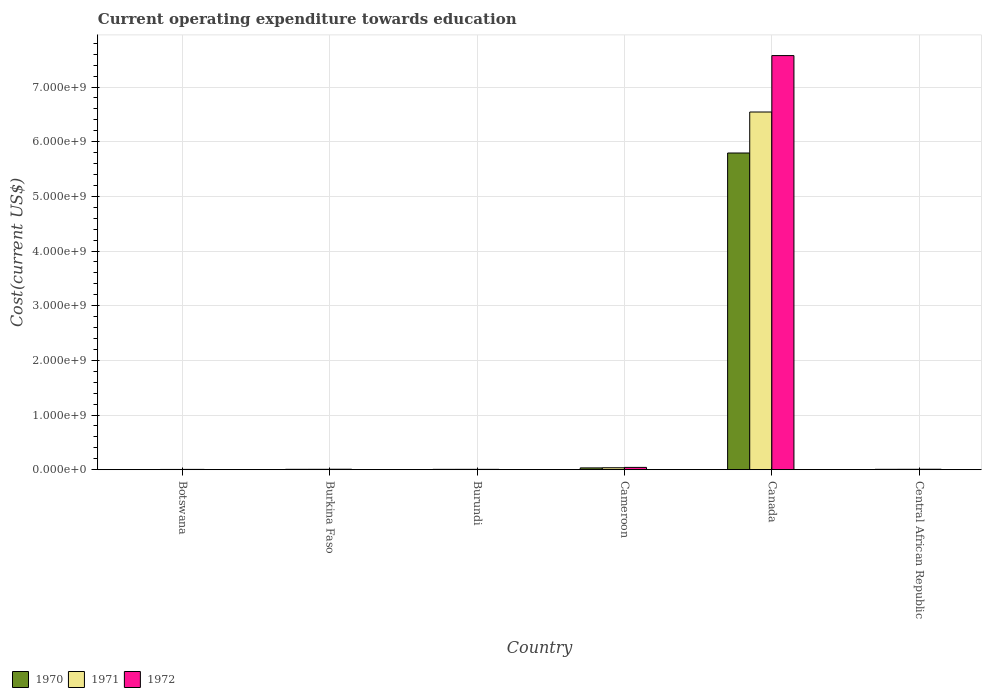How many groups of bars are there?
Keep it short and to the point. 6. Are the number of bars per tick equal to the number of legend labels?
Offer a very short reply. Yes. Are the number of bars on each tick of the X-axis equal?
Keep it short and to the point. Yes. What is the label of the 4th group of bars from the left?
Keep it short and to the point. Cameroon. In how many cases, is the number of bars for a given country not equal to the number of legend labels?
Offer a terse response. 0. What is the expenditure towards education in 1970 in Cameroon?
Offer a terse response. 3.28e+07. Across all countries, what is the maximum expenditure towards education in 1971?
Keep it short and to the point. 6.54e+09. Across all countries, what is the minimum expenditure towards education in 1970?
Keep it short and to the point. 3.52e+06. In which country was the expenditure towards education in 1970 maximum?
Your answer should be very brief. Canada. In which country was the expenditure towards education in 1972 minimum?
Ensure brevity in your answer.  Botswana. What is the total expenditure towards education in 1971 in the graph?
Offer a very short reply. 6.60e+09. What is the difference between the expenditure towards education in 1972 in Burundi and that in Central African Republic?
Your answer should be very brief. -2.09e+06. What is the difference between the expenditure towards education in 1971 in Burkina Faso and the expenditure towards education in 1970 in Burundi?
Give a very brief answer. 8.76e+05. What is the average expenditure towards education in 1970 per country?
Offer a terse response. 9.75e+08. What is the difference between the expenditure towards education of/in 1971 and expenditure towards education of/in 1970 in Central African Republic?
Keep it short and to the point. 4.30e+05. In how many countries, is the expenditure towards education in 1972 greater than 4000000000 US$?
Your answer should be compact. 1. What is the ratio of the expenditure towards education in 1970 in Burundi to that in Canada?
Offer a very short reply. 0. What is the difference between the highest and the second highest expenditure towards education in 1972?
Keep it short and to the point. 7.53e+09. What is the difference between the highest and the lowest expenditure towards education in 1971?
Your answer should be compact. 6.54e+09. What does the 2nd bar from the left in Burundi represents?
Your response must be concise. 1971. Is it the case that in every country, the sum of the expenditure towards education in 1970 and expenditure towards education in 1971 is greater than the expenditure towards education in 1972?
Provide a succinct answer. Yes. What is the difference between two consecutive major ticks on the Y-axis?
Offer a very short reply. 1.00e+09. Are the values on the major ticks of Y-axis written in scientific E-notation?
Offer a terse response. Yes. What is the title of the graph?
Ensure brevity in your answer.  Current operating expenditure towards education. Does "1961" appear as one of the legend labels in the graph?
Keep it short and to the point. No. What is the label or title of the X-axis?
Provide a short and direct response. Country. What is the label or title of the Y-axis?
Your response must be concise. Cost(current US$). What is the Cost(current US$) in 1970 in Botswana?
Offer a terse response. 3.52e+06. What is the Cost(current US$) of 1971 in Botswana?
Offer a very short reply. 4.56e+06. What is the Cost(current US$) in 1972 in Botswana?
Ensure brevity in your answer.  5.45e+06. What is the Cost(current US$) in 1970 in Burkina Faso?
Provide a short and direct response. 6.88e+06. What is the Cost(current US$) in 1971 in Burkina Faso?
Give a very brief answer. 7.23e+06. What is the Cost(current US$) in 1972 in Burkina Faso?
Offer a terse response. 8.66e+06. What is the Cost(current US$) of 1970 in Burundi?
Offer a very short reply. 6.35e+06. What is the Cost(current US$) in 1971 in Burundi?
Make the answer very short. 6.58e+06. What is the Cost(current US$) in 1972 in Burundi?
Offer a very short reply. 6.36e+06. What is the Cost(current US$) of 1970 in Cameroon?
Make the answer very short. 3.28e+07. What is the Cost(current US$) of 1971 in Cameroon?
Make the answer very short. 3.57e+07. What is the Cost(current US$) in 1972 in Cameroon?
Provide a short and direct response. 4.21e+07. What is the Cost(current US$) of 1970 in Canada?
Keep it short and to the point. 5.79e+09. What is the Cost(current US$) of 1971 in Canada?
Make the answer very short. 6.54e+09. What is the Cost(current US$) in 1972 in Canada?
Your answer should be very brief. 7.58e+09. What is the Cost(current US$) of 1970 in Central African Republic?
Your response must be concise. 6.93e+06. What is the Cost(current US$) of 1971 in Central African Republic?
Ensure brevity in your answer.  7.36e+06. What is the Cost(current US$) of 1972 in Central African Republic?
Keep it short and to the point. 8.45e+06. Across all countries, what is the maximum Cost(current US$) in 1970?
Offer a very short reply. 5.79e+09. Across all countries, what is the maximum Cost(current US$) of 1971?
Offer a very short reply. 6.54e+09. Across all countries, what is the maximum Cost(current US$) in 1972?
Your response must be concise. 7.58e+09. Across all countries, what is the minimum Cost(current US$) in 1970?
Provide a short and direct response. 3.52e+06. Across all countries, what is the minimum Cost(current US$) in 1971?
Your answer should be compact. 4.56e+06. Across all countries, what is the minimum Cost(current US$) in 1972?
Keep it short and to the point. 5.45e+06. What is the total Cost(current US$) of 1970 in the graph?
Provide a short and direct response. 5.85e+09. What is the total Cost(current US$) of 1971 in the graph?
Offer a very short reply. 6.60e+09. What is the total Cost(current US$) in 1972 in the graph?
Keep it short and to the point. 7.65e+09. What is the difference between the Cost(current US$) of 1970 in Botswana and that in Burkina Faso?
Offer a terse response. -3.35e+06. What is the difference between the Cost(current US$) of 1971 in Botswana and that in Burkina Faso?
Provide a short and direct response. -2.66e+06. What is the difference between the Cost(current US$) of 1972 in Botswana and that in Burkina Faso?
Give a very brief answer. -3.21e+06. What is the difference between the Cost(current US$) in 1970 in Botswana and that in Burundi?
Your response must be concise. -2.83e+06. What is the difference between the Cost(current US$) in 1971 in Botswana and that in Burundi?
Offer a terse response. -2.02e+06. What is the difference between the Cost(current US$) in 1972 in Botswana and that in Burundi?
Ensure brevity in your answer.  -9.03e+05. What is the difference between the Cost(current US$) of 1970 in Botswana and that in Cameroon?
Provide a succinct answer. -2.93e+07. What is the difference between the Cost(current US$) in 1971 in Botswana and that in Cameroon?
Give a very brief answer. -3.12e+07. What is the difference between the Cost(current US$) in 1972 in Botswana and that in Cameroon?
Give a very brief answer. -3.66e+07. What is the difference between the Cost(current US$) in 1970 in Botswana and that in Canada?
Your response must be concise. -5.79e+09. What is the difference between the Cost(current US$) in 1971 in Botswana and that in Canada?
Provide a succinct answer. -6.54e+09. What is the difference between the Cost(current US$) of 1972 in Botswana and that in Canada?
Give a very brief answer. -7.57e+09. What is the difference between the Cost(current US$) in 1970 in Botswana and that in Central African Republic?
Your response must be concise. -3.41e+06. What is the difference between the Cost(current US$) of 1971 in Botswana and that in Central African Republic?
Give a very brief answer. -2.80e+06. What is the difference between the Cost(current US$) in 1972 in Botswana and that in Central African Republic?
Your answer should be very brief. -2.99e+06. What is the difference between the Cost(current US$) in 1970 in Burkina Faso and that in Burundi?
Ensure brevity in your answer.  5.23e+05. What is the difference between the Cost(current US$) of 1971 in Burkina Faso and that in Burundi?
Offer a terse response. 6.47e+05. What is the difference between the Cost(current US$) of 1972 in Burkina Faso and that in Burundi?
Provide a short and direct response. 2.30e+06. What is the difference between the Cost(current US$) of 1970 in Burkina Faso and that in Cameroon?
Your answer should be very brief. -2.59e+07. What is the difference between the Cost(current US$) in 1971 in Burkina Faso and that in Cameroon?
Your answer should be compact. -2.85e+07. What is the difference between the Cost(current US$) of 1972 in Burkina Faso and that in Cameroon?
Give a very brief answer. -3.34e+07. What is the difference between the Cost(current US$) of 1970 in Burkina Faso and that in Canada?
Your answer should be very brief. -5.79e+09. What is the difference between the Cost(current US$) in 1971 in Burkina Faso and that in Canada?
Your answer should be compact. -6.54e+09. What is the difference between the Cost(current US$) of 1972 in Burkina Faso and that in Canada?
Your answer should be compact. -7.57e+09. What is the difference between the Cost(current US$) of 1970 in Burkina Faso and that in Central African Republic?
Provide a succinct answer. -5.43e+04. What is the difference between the Cost(current US$) of 1971 in Burkina Faso and that in Central African Republic?
Your answer should be very brief. -1.32e+05. What is the difference between the Cost(current US$) in 1972 in Burkina Faso and that in Central African Republic?
Your response must be concise. 2.14e+05. What is the difference between the Cost(current US$) of 1970 in Burundi and that in Cameroon?
Provide a succinct answer. -2.64e+07. What is the difference between the Cost(current US$) in 1971 in Burundi and that in Cameroon?
Offer a very short reply. -2.91e+07. What is the difference between the Cost(current US$) in 1972 in Burundi and that in Cameroon?
Ensure brevity in your answer.  -3.57e+07. What is the difference between the Cost(current US$) of 1970 in Burundi and that in Canada?
Keep it short and to the point. -5.79e+09. What is the difference between the Cost(current US$) of 1971 in Burundi and that in Canada?
Offer a terse response. -6.54e+09. What is the difference between the Cost(current US$) of 1972 in Burundi and that in Canada?
Your response must be concise. -7.57e+09. What is the difference between the Cost(current US$) in 1970 in Burundi and that in Central African Republic?
Provide a succinct answer. -5.78e+05. What is the difference between the Cost(current US$) in 1971 in Burundi and that in Central African Republic?
Provide a short and direct response. -7.79e+05. What is the difference between the Cost(current US$) of 1972 in Burundi and that in Central African Republic?
Your answer should be very brief. -2.09e+06. What is the difference between the Cost(current US$) in 1970 in Cameroon and that in Canada?
Give a very brief answer. -5.76e+09. What is the difference between the Cost(current US$) of 1971 in Cameroon and that in Canada?
Make the answer very short. -6.51e+09. What is the difference between the Cost(current US$) in 1972 in Cameroon and that in Canada?
Your answer should be very brief. -7.53e+09. What is the difference between the Cost(current US$) of 1970 in Cameroon and that in Central African Republic?
Provide a short and direct response. 2.59e+07. What is the difference between the Cost(current US$) of 1971 in Cameroon and that in Central African Republic?
Ensure brevity in your answer.  2.84e+07. What is the difference between the Cost(current US$) of 1972 in Cameroon and that in Central African Republic?
Offer a very short reply. 3.36e+07. What is the difference between the Cost(current US$) in 1970 in Canada and that in Central African Republic?
Ensure brevity in your answer.  5.79e+09. What is the difference between the Cost(current US$) in 1971 in Canada and that in Central African Republic?
Provide a succinct answer. 6.54e+09. What is the difference between the Cost(current US$) in 1972 in Canada and that in Central African Republic?
Offer a very short reply. 7.57e+09. What is the difference between the Cost(current US$) of 1970 in Botswana and the Cost(current US$) of 1971 in Burkina Faso?
Offer a very short reply. -3.71e+06. What is the difference between the Cost(current US$) in 1970 in Botswana and the Cost(current US$) in 1972 in Burkina Faso?
Your answer should be compact. -5.14e+06. What is the difference between the Cost(current US$) of 1971 in Botswana and the Cost(current US$) of 1972 in Burkina Faso?
Keep it short and to the point. -4.09e+06. What is the difference between the Cost(current US$) in 1970 in Botswana and the Cost(current US$) in 1971 in Burundi?
Your answer should be very brief. -3.06e+06. What is the difference between the Cost(current US$) of 1970 in Botswana and the Cost(current US$) of 1972 in Burundi?
Your answer should be very brief. -2.83e+06. What is the difference between the Cost(current US$) in 1971 in Botswana and the Cost(current US$) in 1972 in Burundi?
Keep it short and to the point. -1.79e+06. What is the difference between the Cost(current US$) in 1970 in Botswana and the Cost(current US$) in 1971 in Cameroon?
Give a very brief answer. -3.22e+07. What is the difference between the Cost(current US$) of 1970 in Botswana and the Cost(current US$) of 1972 in Cameroon?
Offer a terse response. -3.86e+07. What is the difference between the Cost(current US$) of 1971 in Botswana and the Cost(current US$) of 1972 in Cameroon?
Make the answer very short. -3.75e+07. What is the difference between the Cost(current US$) of 1970 in Botswana and the Cost(current US$) of 1971 in Canada?
Provide a succinct answer. -6.54e+09. What is the difference between the Cost(current US$) of 1970 in Botswana and the Cost(current US$) of 1972 in Canada?
Ensure brevity in your answer.  -7.57e+09. What is the difference between the Cost(current US$) in 1971 in Botswana and the Cost(current US$) in 1972 in Canada?
Provide a succinct answer. -7.57e+09. What is the difference between the Cost(current US$) of 1970 in Botswana and the Cost(current US$) of 1971 in Central African Republic?
Your response must be concise. -3.84e+06. What is the difference between the Cost(current US$) of 1970 in Botswana and the Cost(current US$) of 1972 in Central African Republic?
Ensure brevity in your answer.  -4.92e+06. What is the difference between the Cost(current US$) in 1971 in Botswana and the Cost(current US$) in 1972 in Central African Republic?
Ensure brevity in your answer.  -3.88e+06. What is the difference between the Cost(current US$) of 1970 in Burkina Faso and the Cost(current US$) of 1971 in Burundi?
Ensure brevity in your answer.  2.94e+05. What is the difference between the Cost(current US$) of 1970 in Burkina Faso and the Cost(current US$) of 1972 in Burundi?
Make the answer very short. 5.20e+05. What is the difference between the Cost(current US$) in 1971 in Burkina Faso and the Cost(current US$) in 1972 in Burundi?
Your answer should be compact. 8.73e+05. What is the difference between the Cost(current US$) in 1970 in Burkina Faso and the Cost(current US$) in 1971 in Cameroon?
Provide a short and direct response. -2.89e+07. What is the difference between the Cost(current US$) of 1970 in Burkina Faso and the Cost(current US$) of 1972 in Cameroon?
Offer a very short reply. -3.52e+07. What is the difference between the Cost(current US$) of 1971 in Burkina Faso and the Cost(current US$) of 1972 in Cameroon?
Provide a succinct answer. -3.49e+07. What is the difference between the Cost(current US$) in 1970 in Burkina Faso and the Cost(current US$) in 1971 in Canada?
Provide a succinct answer. -6.54e+09. What is the difference between the Cost(current US$) in 1970 in Burkina Faso and the Cost(current US$) in 1972 in Canada?
Offer a very short reply. -7.57e+09. What is the difference between the Cost(current US$) of 1971 in Burkina Faso and the Cost(current US$) of 1972 in Canada?
Provide a short and direct response. -7.57e+09. What is the difference between the Cost(current US$) in 1970 in Burkina Faso and the Cost(current US$) in 1971 in Central African Republic?
Offer a very short reply. -4.85e+05. What is the difference between the Cost(current US$) in 1970 in Burkina Faso and the Cost(current US$) in 1972 in Central African Republic?
Offer a terse response. -1.57e+06. What is the difference between the Cost(current US$) in 1971 in Burkina Faso and the Cost(current US$) in 1972 in Central African Republic?
Offer a very short reply. -1.22e+06. What is the difference between the Cost(current US$) in 1970 in Burundi and the Cost(current US$) in 1971 in Cameroon?
Offer a terse response. -2.94e+07. What is the difference between the Cost(current US$) in 1970 in Burundi and the Cost(current US$) in 1972 in Cameroon?
Keep it short and to the point. -3.57e+07. What is the difference between the Cost(current US$) in 1971 in Burundi and the Cost(current US$) in 1972 in Cameroon?
Ensure brevity in your answer.  -3.55e+07. What is the difference between the Cost(current US$) of 1970 in Burundi and the Cost(current US$) of 1971 in Canada?
Keep it short and to the point. -6.54e+09. What is the difference between the Cost(current US$) in 1970 in Burundi and the Cost(current US$) in 1972 in Canada?
Your response must be concise. -7.57e+09. What is the difference between the Cost(current US$) in 1971 in Burundi and the Cost(current US$) in 1972 in Canada?
Your response must be concise. -7.57e+09. What is the difference between the Cost(current US$) in 1970 in Burundi and the Cost(current US$) in 1971 in Central African Republic?
Your response must be concise. -1.01e+06. What is the difference between the Cost(current US$) in 1970 in Burundi and the Cost(current US$) in 1972 in Central African Republic?
Make the answer very short. -2.09e+06. What is the difference between the Cost(current US$) in 1971 in Burundi and the Cost(current US$) in 1972 in Central African Republic?
Your answer should be very brief. -1.86e+06. What is the difference between the Cost(current US$) of 1970 in Cameroon and the Cost(current US$) of 1971 in Canada?
Your response must be concise. -6.51e+09. What is the difference between the Cost(current US$) of 1970 in Cameroon and the Cost(current US$) of 1972 in Canada?
Give a very brief answer. -7.54e+09. What is the difference between the Cost(current US$) in 1971 in Cameroon and the Cost(current US$) in 1972 in Canada?
Your response must be concise. -7.54e+09. What is the difference between the Cost(current US$) of 1970 in Cameroon and the Cost(current US$) of 1971 in Central African Republic?
Your response must be concise. 2.54e+07. What is the difference between the Cost(current US$) in 1970 in Cameroon and the Cost(current US$) in 1972 in Central African Republic?
Make the answer very short. 2.43e+07. What is the difference between the Cost(current US$) in 1971 in Cameroon and the Cost(current US$) in 1972 in Central African Republic?
Offer a terse response. 2.73e+07. What is the difference between the Cost(current US$) in 1970 in Canada and the Cost(current US$) in 1971 in Central African Republic?
Keep it short and to the point. 5.79e+09. What is the difference between the Cost(current US$) of 1970 in Canada and the Cost(current US$) of 1972 in Central African Republic?
Your answer should be compact. 5.78e+09. What is the difference between the Cost(current US$) of 1971 in Canada and the Cost(current US$) of 1972 in Central African Republic?
Ensure brevity in your answer.  6.54e+09. What is the average Cost(current US$) of 1970 per country?
Offer a terse response. 9.75e+08. What is the average Cost(current US$) in 1971 per country?
Provide a succinct answer. 1.10e+09. What is the average Cost(current US$) in 1972 per country?
Give a very brief answer. 1.27e+09. What is the difference between the Cost(current US$) of 1970 and Cost(current US$) of 1971 in Botswana?
Keep it short and to the point. -1.04e+06. What is the difference between the Cost(current US$) in 1970 and Cost(current US$) in 1972 in Botswana?
Provide a short and direct response. -1.93e+06. What is the difference between the Cost(current US$) of 1971 and Cost(current US$) of 1972 in Botswana?
Provide a short and direct response. -8.89e+05. What is the difference between the Cost(current US$) in 1970 and Cost(current US$) in 1971 in Burkina Faso?
Provide a short and direct response. -3.53e+05. What is the difference between the Cost(current US$) in 1970 and Cost(current US$) in 1972 in Burkina Faso?
Give a very brief answer. -1.78e+06. What is the difference between the Cost(current US$) in 1971 and Cost(current US$) in 1972 in Burkina Faso?
Give a very brief answer. -1.43e+06. What is the difference between the Cost(current US$) of 1970 and Cost(current US$) of 1971 in Burundi?
Provide a succinct answer. -2.29e+05. What is the difference between the Cost(current US$) of 1970 and Cost(current US$) of 1972 in Burundi?
Keep it short and to the point. -3332.57. What is the difference between the Cost(current US$) in 1971 and Cost(current US$) in 1972 in Burundi?
Offer a terse response. 2.26e+05. What is the difference between the Cost(current US$) of 1970 and Cost(current US$) of 1971 in Cameroon?
Provide a succinct answer. -2.94e+06. What is the difference between the Cost(current US$) in 1970 and Cost(current US$) in 1972 in Cameroon?
Ensure brevity in your answer.  -9.29e+06. What is the difference between the Cost(current US$) of 1971 and Cost(current US$) of 1972 in Cameroon?
Your response must be concise. -6.35e+06. What is the difference between the Cost(current US$) of 1970 and Cost(current US$) of 1971 in Canada?
Offer a terse response. -7.50e+08. What is the difference between the Cost(current US$) of 1970 and Cost(current US$) of 1972 in Canada?
Offer a terse response. -1.78e+09. What is the difference between the Cost(current US$) of 1971 and Cost(current US$) of 1972 in Canada?
Ensure brevity in your answer.  -1.03e+09. What is the difference between the Cost(current US$) of 1970 and Cost(current US$) of 1971 in Central African Republic?
Offer a terse response. -4.30e+05. What is the difference between the Cost(current US$) of 1970 and Cost(current US$) of 1972 in Central African Republic?
Keep it short and to the point. -1.51e+06. What is the difference between the Cost(current US$) in 1971 and Cost(current US$) in 1972 in Central African Republic?
Give a very brief answer. -1.08e+06. What is the ratio of the Cost(current US$) of 1970 in Botswana to that in Burkina Faso?
Your answer should be very brief. 0.51. What is the ratio of the Cost(current US$) in 1971 in Botswana to that in Burkina Faso?
Give a very brief answer. 0.63. What is the ratio of the Cost(current US$) of 1972 in Botswana to that in Burkina Faso?
Offer a very short reply. 0.63. What is the ratio of the Cost(current US$) of 1970 in Botswana to that in Burundi?
Give a very brief answer. 0.55. What is the ratio of the Cost(current US$) in 1971 in Botswana to that in Burundi?
Keep it short and to the point. 0.69. What is the ratio of the Cost(current US$) of 1972 in Botswana to that in Burundi?
Your answer should be compact. 0.86. What is the ratio of the Cost(current US$) in 1970 in Botswana to that in Cameroon?
Your response must be concise. 0.11. What is the ratio of the Cost(current US$) of 1971 in Botswana to that in Cameroon?
Your answer should be compact. 0.13. What is the ratio of the Cost(current US$) of 1972 in Botswana to that in Cameroon?
Ensure brevity in your answer.  0.13. What is the ratio of the Cost(current US$) in 1970 in Botswana to that in Canada?
Provide a succinct answer. 0. What is the ratio of the Cost(current US$) of 1971 in Botswana to that in Canada?
Ensure brevity in your answer.  0. What is the ratio of the Cost(current US$) of 1972 in Botswana to that in Canada?
Keep it short and to the point. 0. What is the ratio of the Cost(current US$) of 1970 in Botswana to that in Central African Republic?
Your answer should be very brief. 0.51. What is the ratio of the Cost(current US$) of 1971 in Botswana to that in Central African Republic?
Your answer should be compact. 0.62. What is the ratio of the Cost(current US$) of 1972 in Botswana to that in Central African Republic?
Offer a terse response. 0.65. What is the ratio of the Cost(current US$) of 1970 in Burkina Faso to that in Burundi?
Offer a very short reply. 1.08. What is the ratio of the Cost(current US$) in 1971 in Burkina Faso to that in Burundi?
Your answer should be compact. 1.1. What is the ratio of the Cost(current US$) of 1972 in Burkina Faso to that in Burundi?
Provide a succinct answer. 1.36. What is the ratio of the Cost(current US$) in 1970 in Burkina Faso to that in Cameroon?
Keep it short and to the point. 0.21. What is the ratio of the Cost(current US$) of 1971 in Burkina Faso to that in Cameroon?
Offer a very short reply. 0.2. What is the ratio of the Cost(current US$) in 1972 in Burkina Faso to that in Cameroon?
Ensure brevity in your answer.  0.21. What is the ratio of the Cost(current US$) in 1970 in Burkina Faso to that in Canada?
Provide a succinct answer. 0. What is the ratio of the Cost(current US$) of 1971 in Burkina Faso to that in Canada?
Give a very brief answer. 0. What is the ratio of the Cost(current US$) in 1972 in Burkina Faso to that in Canada?
Provide a short and direct response. 0. What is the ratio of the Cost(current US$) in 1972 in Burkina Faso to that in Central African Republic?
Make the answer very short. 1.03. What is the ratio of the Cost(current US$) in 1970 in Burundi to that in Cameroon?
Make the answer very short. 0.19. What is the ratio of the Cost(current US$) in 1971 in Burundi to that in Cameroon?
Offer a terse response. 0.18. What is the ratio of the Cost(current US$) of 1972 in Burundi to that in Cameroon?
Offer a terse response. 0.15. What is the ratio of the Cost(current US$) of 1970 in Burundi to that in Canada?
Make the answer very short. 0. What is the ratio of the Cost(current US$) of 1972 in Burundi to that in Canada?
Make the answer very short. 0. What is the ratio of the Cost(current US$) in 1970 in Burundi to that in Central African Republic?
Give a very brief answer. 0.92. What is the ratio of the Cost(current US$) of 1971 in Burundi to that in Central African Republic?
Give a very brief answer. 0.89. What is the ratio of the Cost(current US$) in 1972 in Burundi to that in Central African Republic?
Provide a succinct answer. 0.75. What is the ratio of the Cost(current US$) in 1970 in Cameroon to that in Canada?
Keep it short and to the point. 0.01. What is the ratio of the Cost(current US$) in 1971 in Cameroon to that in Canada?
Your answer should be very brief. 0.01. What is the ratio of the Cost(current US$) in 1972 in Cameroon to that in Canada?
Your response must be concise. 0.01. What is the ratio of the Cost(current US$) in 1970 in Cameroon to that in Central African Republic?
Ensure brevity in your answer.  4.73. What is the ratio of the Cost(current US$) in 1971 in Cameroon to that in Central African Republic?
Offer a very short reply. 4.85. What is the ratio of the Cost(current US$) of 1972 in Cameroon to that in Central African Republic?
Your answer should be very brief. 4.98. What is the ratio of the Cost(current US$) in 1970 in Canada to that in Central African Republic?
Offer a very short reply. 835.93. What is the ratio of the Cost(current US$) of 1971 in Canada to that in Central African Republic?
Your response must be concise. 888.96. What is the ratio of the Cost(current US$) of 1972 in Canada to that in Central African Republic?
Your response must be concise. 897.04. What is the difference between the highest and the second highest Cost(current US$) in 1970?
Offer a very short reply. 5.76e+09. What is the difference between the highest and the second highest Cost(current US$) in 1971?
Give a very brief answer. 6.51e+09. What is the difference between the highest and the second highest Cost(current US$) of 1972?
Ensure brevity in your answer.  7.53e+09. What is the difference between the highest and the lowest Cost(current US$) of 1970?
Offer a terse response. 5.79e+09. What is the difference between the highest and the lowest Cost(current US$) of 1971?
Your answer should be compact. 6.54e+09. What is the difference between the highest and the lowest Cost(current US$) in 1972?
Your response must be concise. 7.57e+09. 